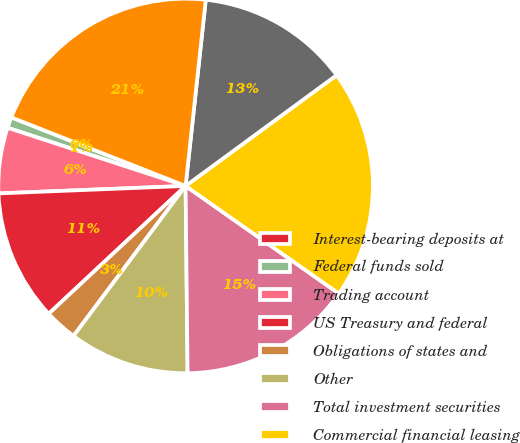<chart> <loc_0><loc_0><loc_500><loc_500><pie_chart><fcel>Interest-bearing deposits at<fcel>Federal funds sold<fcel>Trading account<fcel>US Treasury and federal<fcel>Obligations of states and<fcel>Other<fcel>Total investment securities<fcel>Commercial financial leasing<fcel>Real estate - construction<fcel>Real estate - mortgage<nl><fcel>0.0%<fcel>0.94%<fcel>5.66%<fcel>11.32%<fcel>2.83%<fcel>10.38%<fcel>15.09%<fcel>19.81%<fcel>13.21%<fcel>20.75%<nl></chart> 